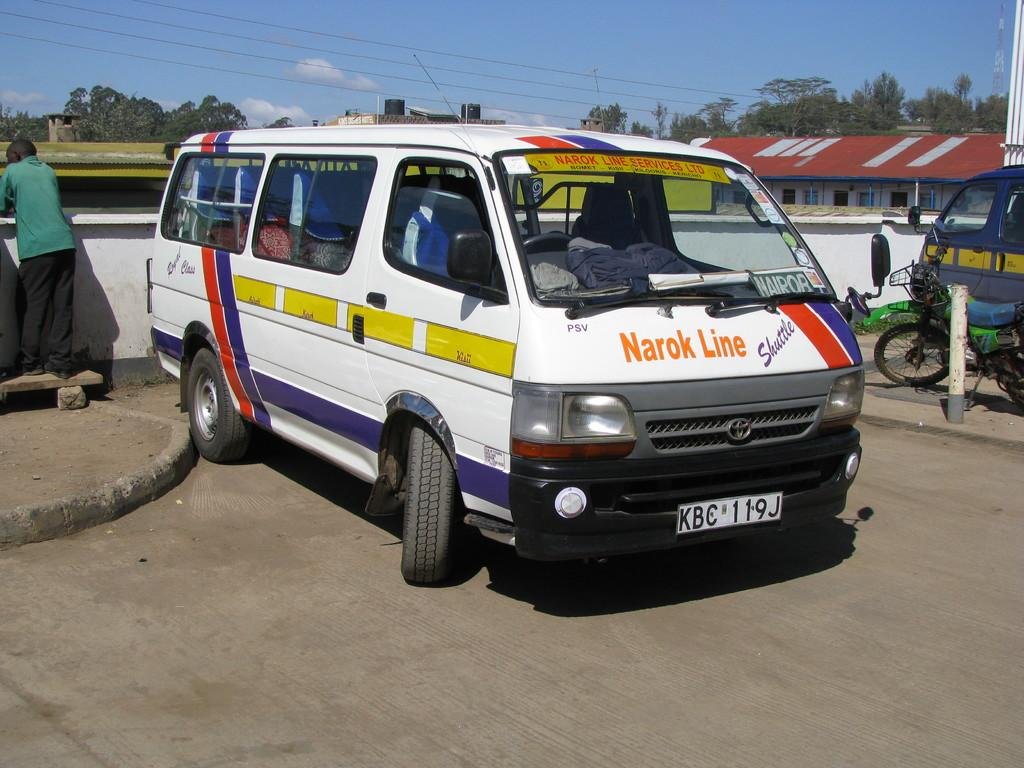<image>
Summarize the visual content of the image. A Narok Line shuttle van is parked and a man is standing behind it. 